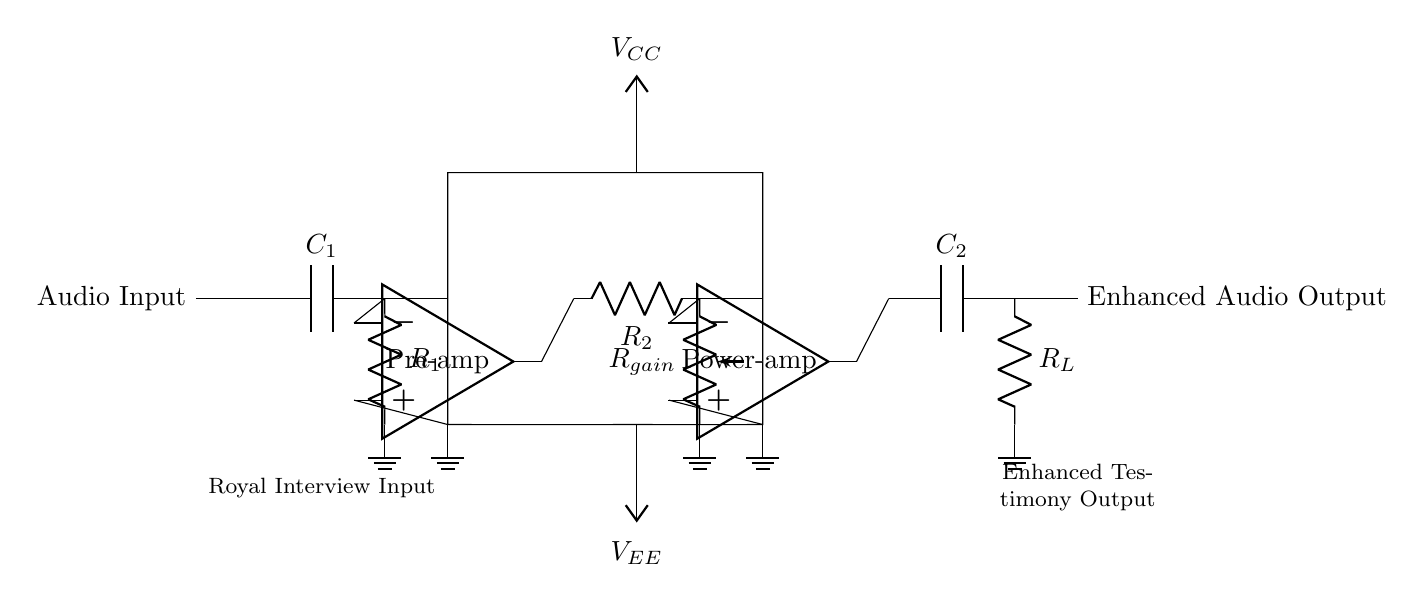What is the purpose of C1 in the circuit? C1 is a coupling capacitor that passes the audio signal while blocking any DC component from the audio input. This allows the circuit to amplify only the desired AC signal, which is essential for enhancing audio recordings.
Answer: Coupling What component controls the gain in this circuit? The gain is controlled by the resistor labeled Rgain. It is adjustable, allowing users to set the desired amplification level of the pre-amplified audio signal.
Answer: Rgain What type of operational amplifier is used in the power amplification stage? The circuit features a power amplifier, indicated as the second operational amplifier in the diagram, which amplifies the already increased audio signal to a level suitable for output.
Answer: Power-amp What is the input type of the circuit labeled as? The input type is labeled "Royal Interview Input," indicating that the circuit is designed to enhance audio recordings specifically from interviews related to royal events or testimonies.
Answer: Royal Interview Input What does R_L represent in the output stage? R_L represents the load resistor, which is connected to the output of the circuit. It is responsible for simulating the load that the amplifier will drive, ensuring proper function and performance of the audio output stage.
Answer: Load resistor How many operational amplifiers are used in the circuit? There are two operational amplifiers used in this circuit: one for the pre-amplification stage and another for the power amplification stage, effectively enhancing the audio signal in two separate steps.
Answer: Two 